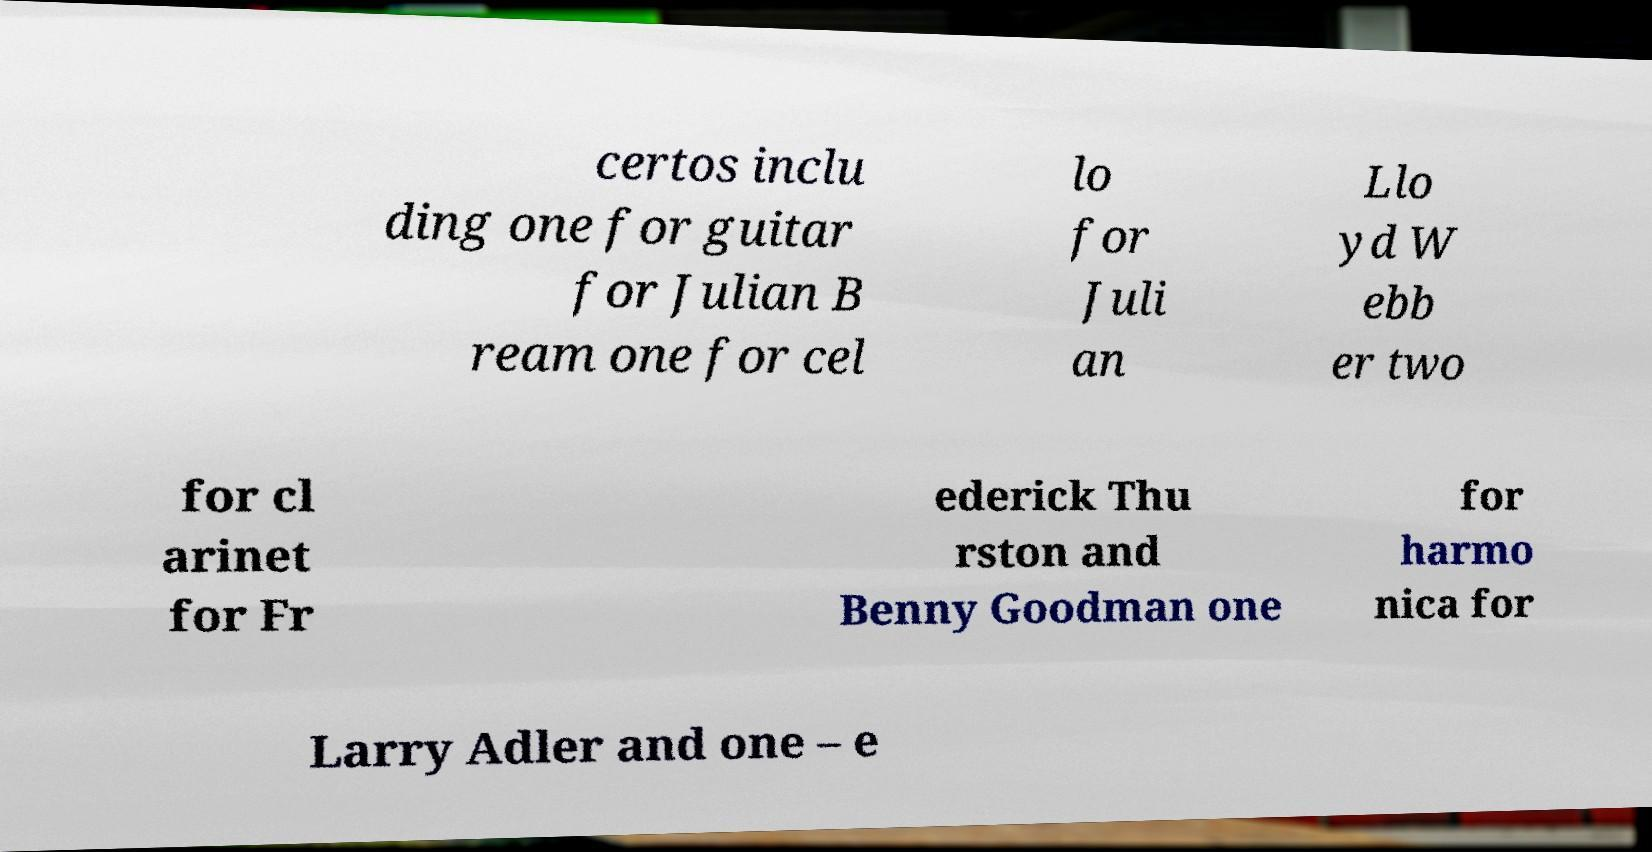Can you read and provide the text displayed in the image?This photo seems to have some interesting text. Can you extract and type it out for me? certos inclu ding one for guitar for Julian B ream one for cel lo for Juli an Llo yd W ebb er two for cl arinet for Fr ederick Thu rston and Benny Goodman one for harmo nica for Larry Adler and one – e 